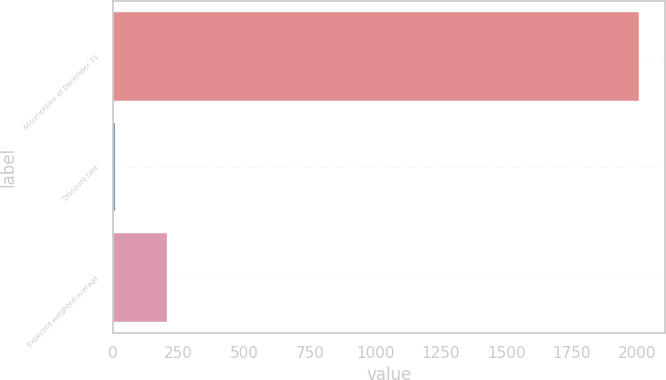Convert chart. <chart><loc_0><loc_0><loc_500><loc_500><bar_chart><fcel>Assumptions at December 31<fcel>Discount rate<fcel>Expected weighted average<nl><fcel>2006<fcel>5.89<fcel>205.9<nl></chart> 